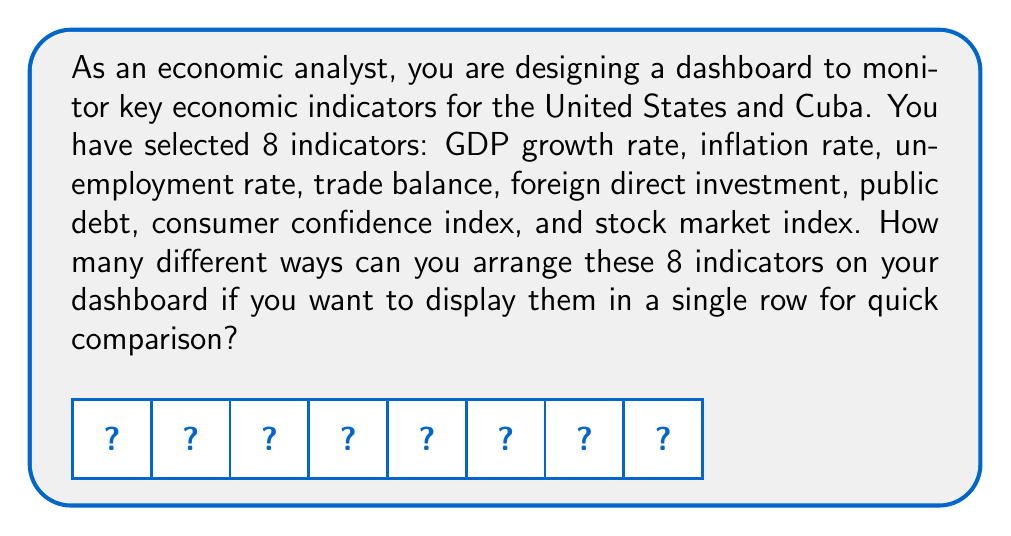Could you help me with this problem? To solve this problem, we need to consider the following steps:

1) We are essentially arranging 8 distinct items (economic indicators) in a line.

2) This is a classic permutation problem. The number of ways to arrange n distinct objects is given by the factorial of n, denoted as n!.

3) In this case, n = 8, so we need to calculate 8!.

4) Let's break down the calculation:

   $$8! = 8 \times 7 \times 6 \times 5 \times 4 \times 3 \times 2 \times 1$$

5) We can compute this step by step:
   
   $$8 \times 7 = 56$$
   $$56 \times 6 = 336$$
   $$336 \times 5 = 1,680$$
   $$1,680 \times 4 = 6,720$$
   $$6,720 \times 3 = 20,160$$
   $$20,160 \times 2 = 40,320$$
   $$40,320 \times 1 = 40,320$$

Therefore, there are 40,320 different ways to arrange the 8 economic indicators on the dashboard.

This large number emphasizes the importance of carefully considering the arrangement of indicators for optimal analysis, as different arrangements might lead to different insights or interpretations of the economic situations in the United States and Cuba.
Answer: 40,320 